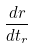<formula> <loc_0><loc_0><loc_500><loc_500>\frac { d r } { d t _ { r } }</formula> 